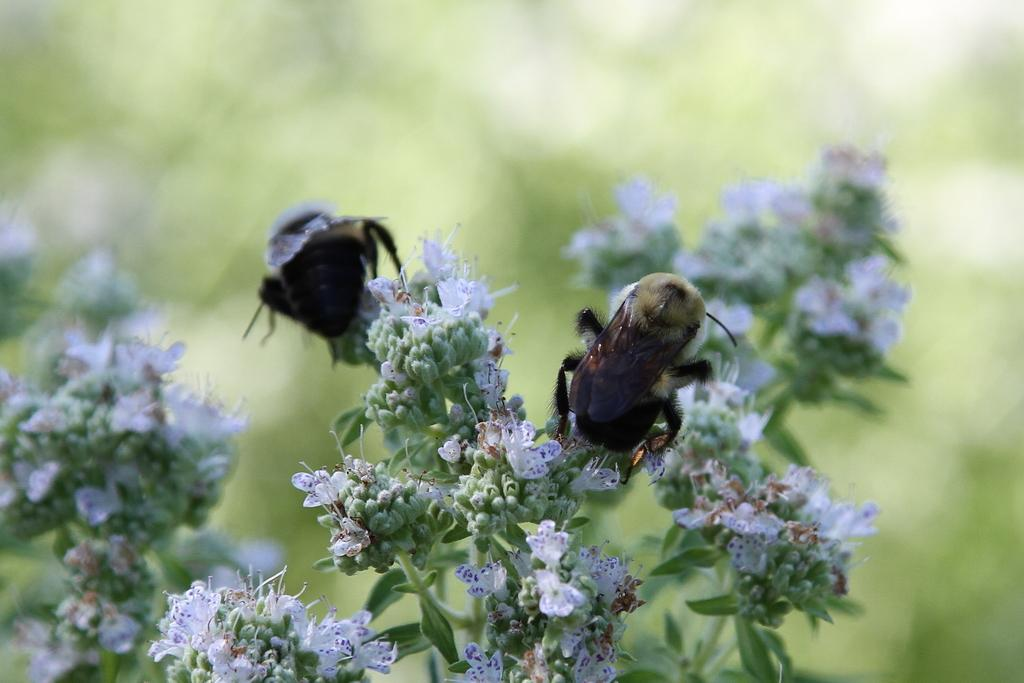How many insects are present in the image? There are two insects in the image. Where are the insects located? The insects are on flowers and plants. Can you describe the background of the image? The background of the image is blurred. What type of arch can be seen in the background of the image? There is no arch present in the background of the image. What kind of flower is the grandfather holding in the image? There is no grandfather or flower present in the image; it features two insects on flowers and plants. 